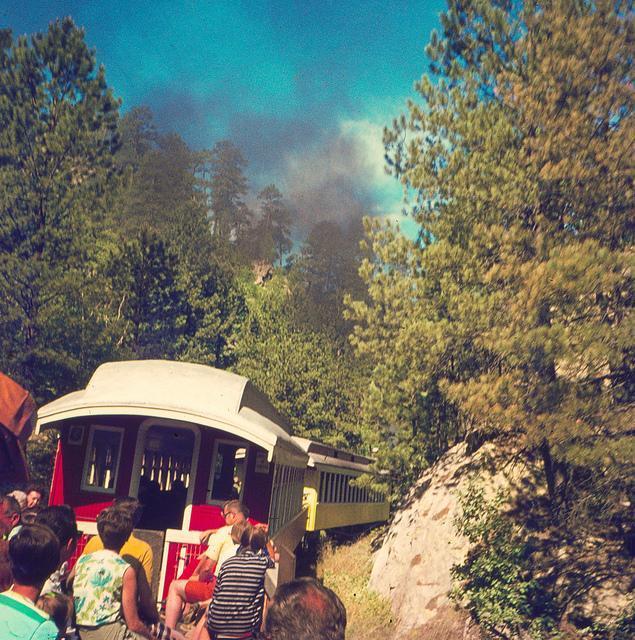How many cars do you see?
Give a very brief answer. 2. How many people are there?
Give a very brief answer. 6. 